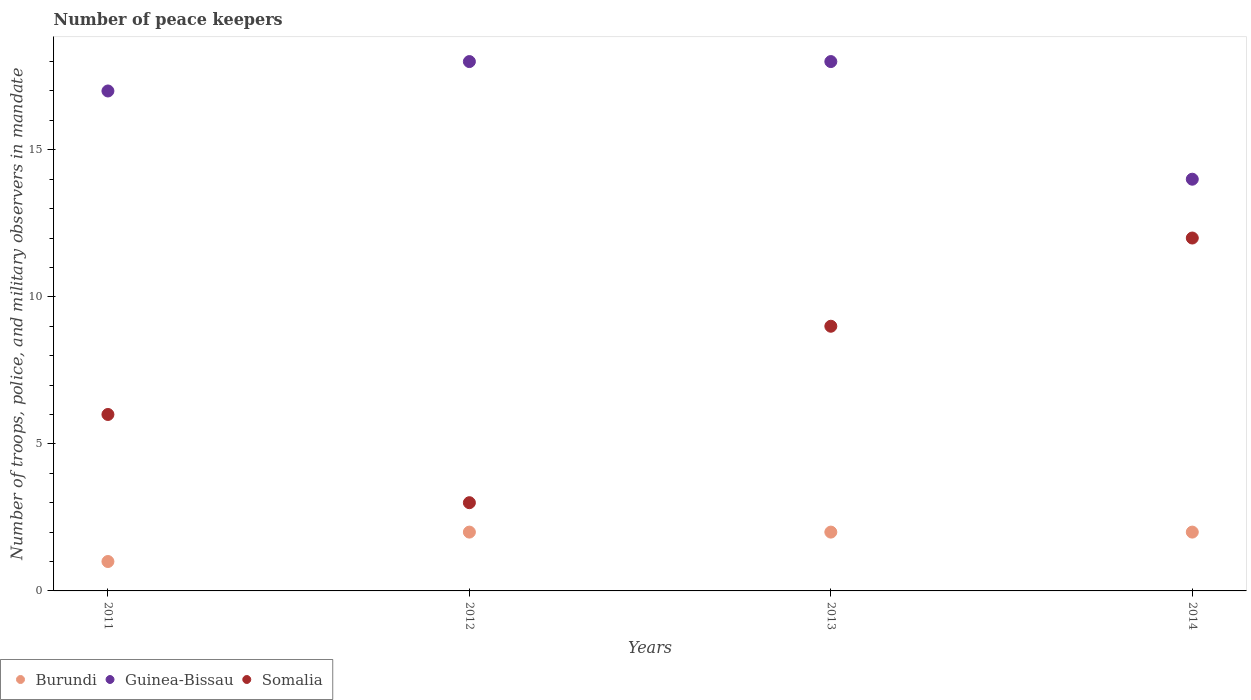Is the number of dotlines equal to the number of legend labels?
Ensure brevity in your answer.  Yes. What is the number of peace keepers in in Somalia in 2012?
Ensure brevity in your answer.  3. Across all years, what is the maximum number of peace keepers in in Somalia?
Provide a short and direct response. 12. In which year was the number of peace keepers in in Guinea-Bissau maximum?
Offer a terse response. 2012. What is the total number of peace keepers in in Somalia in the graph?
Offer a very short reply. 30. What is the average number of peace keepers in in Somalia per year?
Keep it short and to the point. 7.5. In the year 2013, what is the difference between the number of peace keepers in in Guinea-Bissau and number of peace keepers in in Burundi?
Provide a short and direct response. 16. What is the ratio of the number of peace keepers in in Somalia in 2012 to that in 2014?
Your answer should be compact. 0.25. Is the difference between the number of peace keepers in in Guinea-Bissau in 2012 and 2014 greater than the difference between the number of peace keepers in in Burundi in 2012 and 2014?
Provide a short and direct response. Yes. In how many years, is the number of peace keepers in in Somalia greater than the average number of peace keepers in in Somalia taken over all years?
Offer a terse response. 2. Is the sum of the number of peace keepers in in Burundi in 2011 and 2014 greater than the maximum number of peace keepers in in Guinea-Bissau across all years?
Ensure brevity in your answer.  No. Does the number of peace keepers in in Guinea-Bissau monotonically increase over the years?
Offer a terse response. No. Is the number of peace keepers in in Guinea-Bissau strictly greater than the number of peace keepers in in Burundi over the years?
Keep it short and to the point. Yes. How many years are there in the graph?
Offer a terse response. 4. What is the difference between two consecutive major ticks on the Y-axis?
Offer a very short reply. 5. Are the values on the major ticks of Y-axis written in scientific E-notation?
Offer a very short reply. No. Does the graph contain any zero values?
Your response must be concise. No. Does the graph contain grids?
Keep it short and to the point. No. How many legend labels are there?
Ensure brevity in your answer.  3. How are the legend labels stacked?
Keep it short and to the point. Horizontal. What is the title of the graph?
Keep it short and to the point. Number of peace keepers. What is the label or title of the Y-axis?
Your answer should be very brief. Number of troops, police, and military observers in mandate. What is the Number of troops, police, and military observers in mandate of Somalia in 2012?
Ensure brevity in your answer.  3. What is the Number of troops, police, and military observers in mandate in Guinea-Bissau in 2014?
Your answer should be compact. 14. What is the Number of troops, police, and military observers in mandate in Somalia in 2014?
Provide a succinct answer. 12. Across all years, what is the maximum Number of troops, police, and military observers in mandate in Guinea-Bissau?
Offer a terse response. 18. Across all years, what is the minimum Number of troops, police, and military observers in mandate of Guinea-Bissau?
Offer a very short reply. 14. What is the total Number of troops, police, and military observers in mandate of Burundi in the graph?
Ensure brevity in your answer.  7. What is the total Number of troops, police, and military observers in mandate in Somalia in the graph?
Keep it short and to the point. 30. What is the difference between the Number of troops, police, and military observers in mandate of Guinea-Bissau in 2011 and that in 2012?
Keep it short and to the point. -1. What is the difference between the Number of troops, police, and military observers in mandate in Somalia in 2011 and that in 2012?
Make the answer very short. 3. What is the difference between the Number of troops, police, and military observers in mandate of Burundi in 2011 and that in 2013?
Offer a terse response. -1. What is the difference between the Number of troops, police, and military observers in mandate in Guinea-Bissau in 2011 and that in 2013?
Offer a terse response. -1. What is the difference between the Number of troops, police, and military observers in mandate in Somalia in 2011 and that in 2013?
Offer a terse response. -3. What is the difference between the Number of troops, police, and military observers in mandate in Burundi in 2011 and that in 2014?
Provide a succinct answer. -1. What is the difference between the Number of troops, police, and military observers in mandate in Burundi in 2012 and that in 2013?
Provide a short and direct response. 0. What is the difference between the Number of troops, police, and military observers in mandate in Guinea-Bissau in 2012 and that in 2013?
Make the answer very short. 0. What is the difference between the Number of troops, police, and military observers in mandate in Somalia in 2012 and that in 2013?
Ensure brevity in your answer.  -6. What is the difference between the Number of troops, police, and military observers in mandate of Burundi in 2013 and that in 2014?
Provide a short and direct response. 0. What is the difference between the Number of troops, police, and military observers in mandate in Guinea-Bissau in 2013 and that in 2014?
Offer a very short reply. 4. What is the difference between the Number of troops, police, and military observers in mandate of Somalia in 2013 and that in 2014?
Keep it short and to the point. -3. What is the difference between the Number of troops, police, and military observers in mandate of Burundi in 2011 and the Number of troops, police, and military observers in mandate of Guinea-Bissau in 2012?
Your response must be concise. -17. What is the difference between the Number of troops, police, and military observers in mandate of Burundi in 2011 and the Number of troops, police, and military observers in mandate of Somalia in 2012?
Offer a terse response. -2. What is the difference between the Number of troops, police, and military observers in mandate in Burundi in 2011 and the Number of troops, police, and military observers in mandate in Somalia in 2013?
Your response must be concise. -8. What is the difference between the Number of troops, police, and military observers in mandate of Guinea-Bissau in 2011 and the Number of troops, police, and military observers in mandate of Somalia in 2013?
Offer a very short reply. 8. What is the difference between the Number of troops, police, and military observers in mandate in Burundi in 2011 and the Number of troops, police, and military observers in mandate in Somalia in 2014?
Provide a succinct answer. -11. What is the difference between the Number of troops, police, and military observers in mandate in Burundi in 2012 and the Number of troops, police, and military observers in mandate in Guinea-Bissau in 2013?
Your response must be concise. -16. What is the difference between the Number of troops, police, and military observers in mandate in Guinea-Bissau in 2012 and the Number of troops, police, and military observers in mandate in Somalia in 2013?
Your answer should be compact. 9. What is the difference between the Number of troops, police, and military observers in mandate in Burundi in 2013 and the Number of troops, police, and military observers in mandate in Guinea-Bissau in 2014?
Your response must be concise. -12. What is the difference between the Number of troops, police, and military observers in mandate of Burundi in 2013 and the Number of troops, police, and military observers in mandate of Somalia in 2014?
Make the answer very short. -10. What is the average Number of troops, police, and military observers in mandate in Burundi per year?
Keep it short and to the point. 1.75. What is the average Number of troops, police, and military observers in mandate in Guinea-Bissau per year?
Your answer should be compact. 16.75. In the year 2011, what is the difference between the Number of troops, police, and military observers in mandate of Guinea-Bissau and Number of troops, police, and military observers in mandate of Somalia?
Make the answer very short. 11. In the year 2012, what is the difference between the Number of troops, police, and military observers in mandate in Guinea-Bissau and Number of troops, police, and military observers in mandate in Somalia?
Offer a very short reply. 15. In the year 2014, what is the difference between the Number of troops, police, and military observers in mandate of Burundi and Number of troops, police, and military observers in mandate of Guinea-Bissau?
Provide a succinct answer. -12. In the year 2014, what is the difference between the Number of troops, police, and military observers in mandate in Burundi and Number of troops, police, and military observers in mandate in Somalia?
Provide a succinct answer. -10. In the year 2014, what is the difference between the Number of troops, police, and military observers in mandate in Guinea-Bissau and Number of troops, police, and military observers in mandate in Somalia?
Provide a succinct answer. 2. What is the ratio of the Number of troops, police, and military observers in mandate of Guinea-Bissau in 2011 to that in 2012?
Your answer should be compact. 0.94. What is the ratio of the Number of troops, police, and military observers in mandate of Somalia in 2011 to that in 2012?
Your response must be concise. 2. What is the ratio of the Number of troops, police, and military observers in mandate of Burundi in 2011 to that in 2014?
Your answer should be compact. 0.5. What is the ratio of the Number of troops, police, and military observers in mandate in Guinea-Bissau in 2011 to that in 2014?
Offer a very short reply. 1.21. What is the ratio of the Number of troops, police, and military observers in mandate in Guinea-Bissau in 2012 to that in 2013?
Your response must be concise. 1. What is the ratio of the Number of troops, police, and military observers in mandate in Somalia in 2012 to that in 2013?
Keep it short and to the point. 0.33. What is the ratio of the Number of troops, police, and military observers in mandate of Guinea-Bissau in 2012 to that in 2014?
Offer a very short reply. 1.29. What is the ratio of the Number of troops, police, and military observers in mandate of Somalia in 2012 to that in 2014?
Provide a succinct answer. 0.25. What is the ratio of the Number of troops, police, and military observers in mandate of Burundi in 2013 to that in 2014?
Offer a very short reply. 1. What is the ratio of the Number of troops, police, and military observers in mandate of Somalia in 2013 to that in 2014?
Offer a very short reply. 0.75. What is the difference between the highest and the second highest Number of troops, police, and military observers in mandate of Guinea-Bissau?
Provide a succinct answer. 0. What is the difference between the highest and the second highest Number of troops, police, and military observers in mandate in Somalia?
Provide a succinct answer. 3. What is the difference between the highest and the lowest Number of troops, police, and military observers in mandate of Somalia?
Provide a short and direct response. 9. 